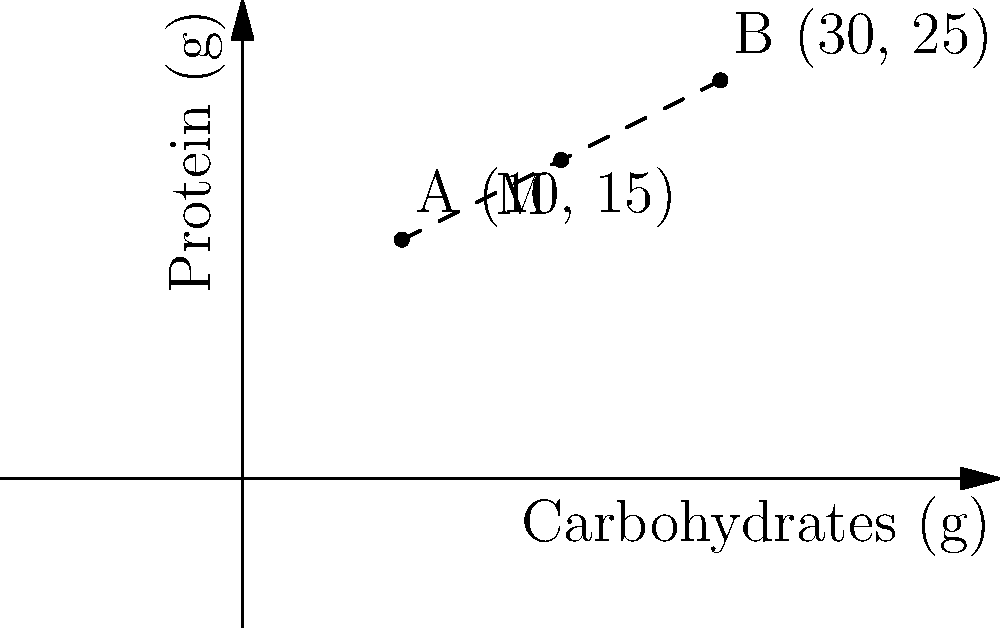Two gluten-free entrees, A and B, are plotted on a coordinate system based on their nutritional content. Entree A is located at (10, 15) and Entree B is at (30, 25), where the x-axis represents carbohydrates (in grams) and the y-axis represents protein (in grams). Find the coordinates of point M, which represents the midpoint between these two entrees. What does this midpoint signify in terms of nutritional content? To find the midpoint M between two points A(x₁, y₁) and B(x₂, y₂), we use the midpoint formula:

$$ M = (\frac{x_1 + x_2}{2}, \frac{y_1 + y_2}{2}) $$

For our entrees:
A(x₁, y₁) = (10, 15)
B(x₂, y₂) = (30, 25)

Step 1: Calculate the x-coordinate of the midpoint:
$$ x_M = \frac{x_1 + x_2}{2} = \frac{10 + 30}{2} = \frac{40}{2} = 20 $$

Step 2: Calculate the y-coordinate of the midpoint:
$$ y_M = \frac{y_1 + y_2}{2} = \frac{15 + 25}{2} = \frac{40}{2} = 20 $$

Therefore, the midpoint M has coordinates (20, 20).

This midpoint signifies an entree that would have the average nutritional content of Entrees A and B, with 20g of carbohydrates and 20g of protein. This information can be useful for menu planning and offering balanced options to customers.
Answer: M(20, 20); average nutritional content 